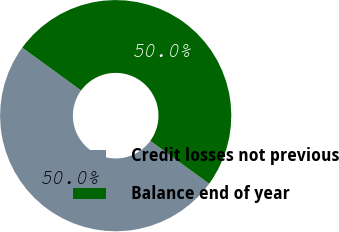Convert chart to OTSL. <chart><loc_0><loc_0><loc_500><loc_500><pie_chart><fcel>Credit losses not previous<fcel>Balance end of year<nl><fcel>50.0%<fcel>50.0%<nl></chart> 